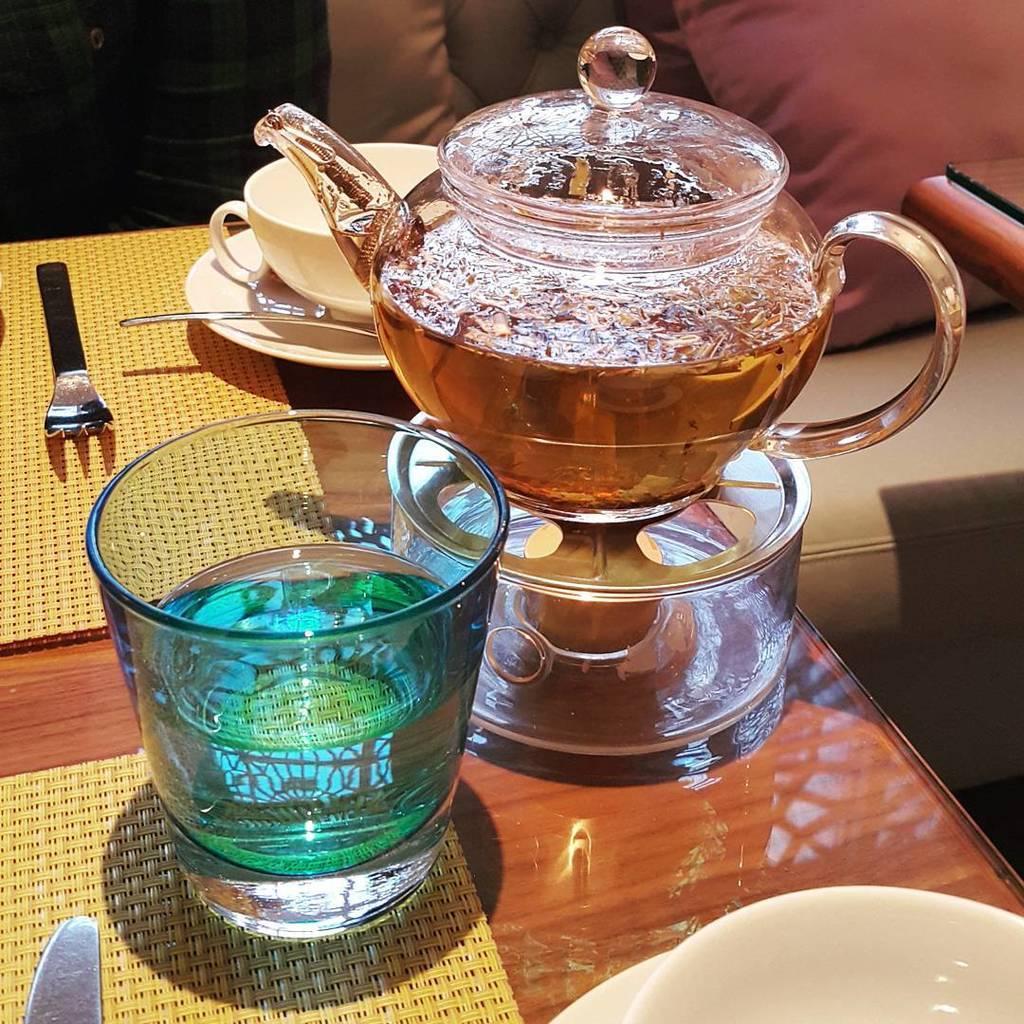Please provide a concise description of this image. On the table we can see water glass, tea bowl, cup, saucer, box, bowl, plate, knife, fork, spoon and mat. On the top right corner there is a pillow on the couch. 